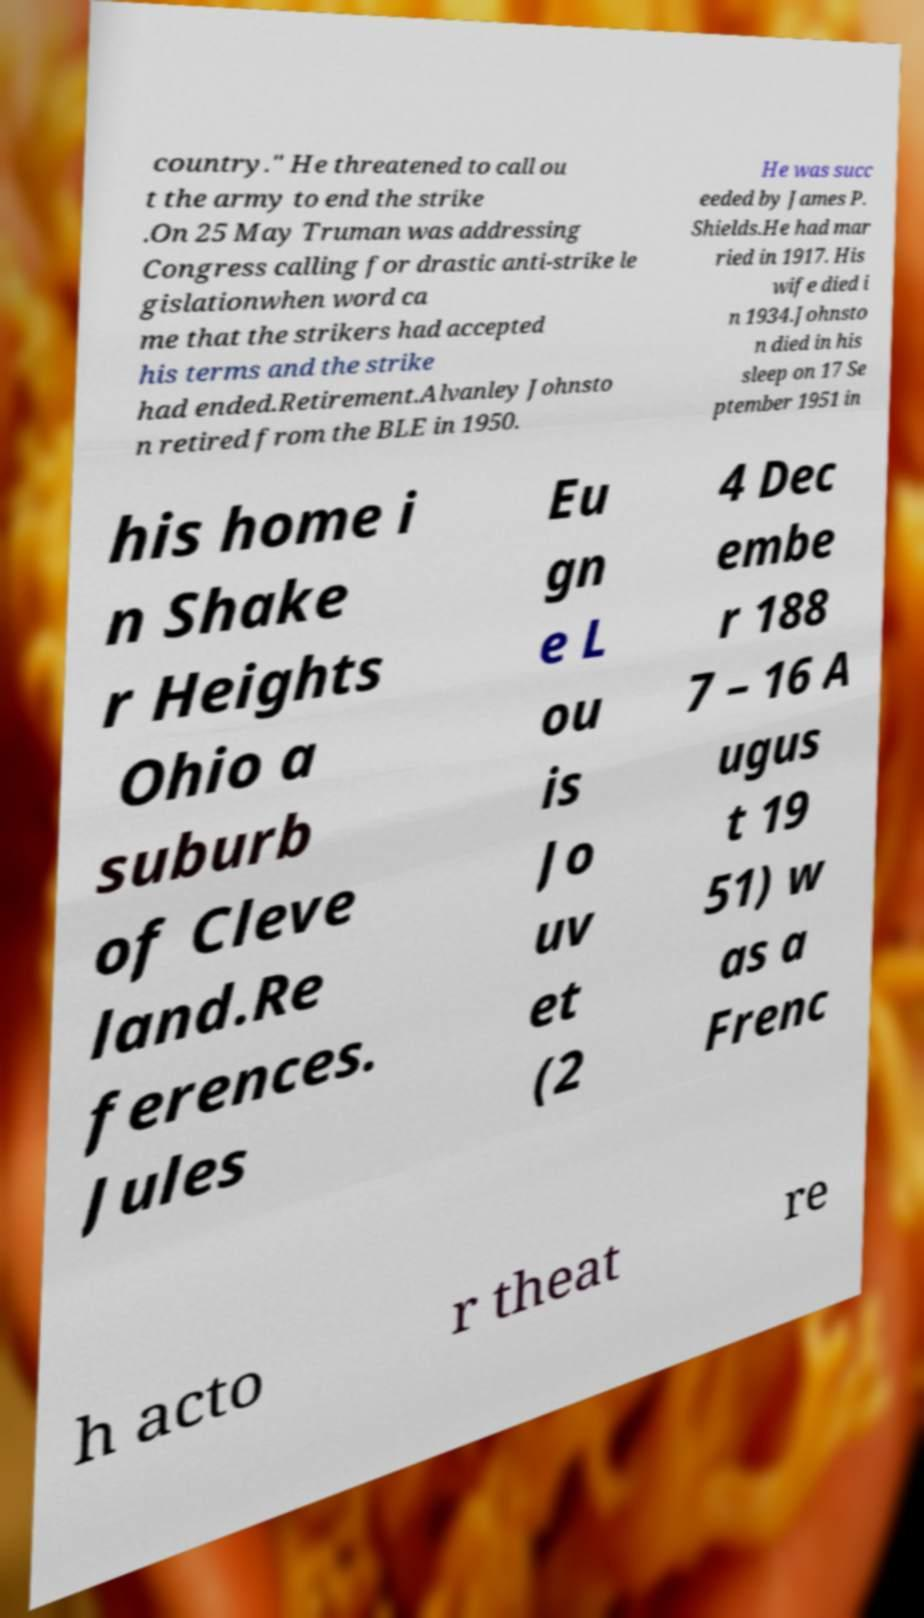Could you assist in decoding the text presented in this image and type it out clearly? country." He threatened to call ou t the army to end the strike .On 25 May Truman was addressing Congress calling for drastic anti-strike le gislationwhen word ca me that the strikers had accepted his terms and the strike had ended.Retirement.Alvanley Johnsto n retired from the BLE in 1950. He was succ eeded by James P. Shields.He had mar ried in 1917. His wife died i n 1934.Johnsto n died in his sleep on 17 Se ptember 1951 in his home i n Shake r Heights Ohio a suburb of Cleve land.Re ferences. Jules Eu gn e L ou is Jo uv et (2 4 Dec embe r 188 7 – 16 A ugus t 19 51) w as a Frenc h acto r theat re 